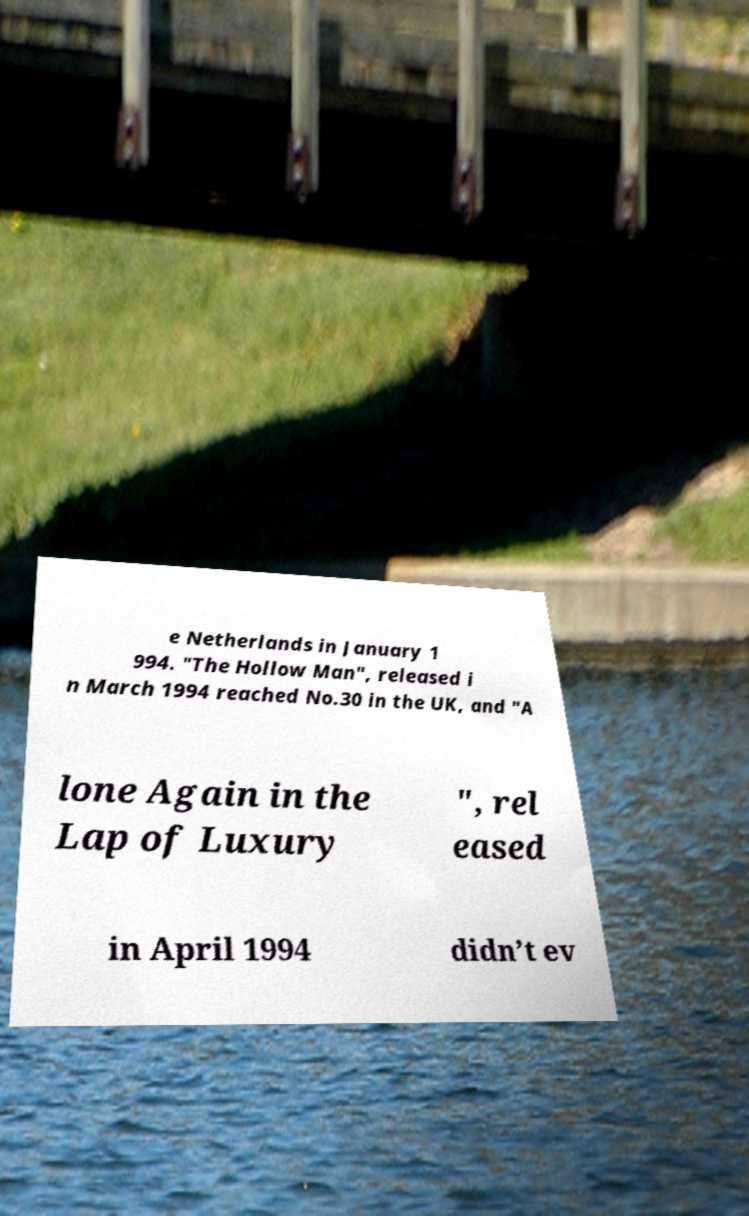Could you assist in decoding the text presented in this image and type it out clearly? e Netherlands in January 1 994. "The Hollow Man", released i n March 1994 reached No.30 in the UK, and "A lone Again in the Lap of Luxury ", rel eased in April 1994 didn’t ev 